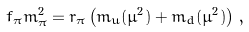Convert formula to latex. <formula><loc_0><loc_0><loc_500><loc_500>f _ { \pi } m _ { \pi } ^ { 2 } = r _ { \pi } \left ( m _ { u } ( \mu ^ { 2 } ) + m _ { d } ( \mu ^ { 2 } ) \right ) \, ,</formula> 